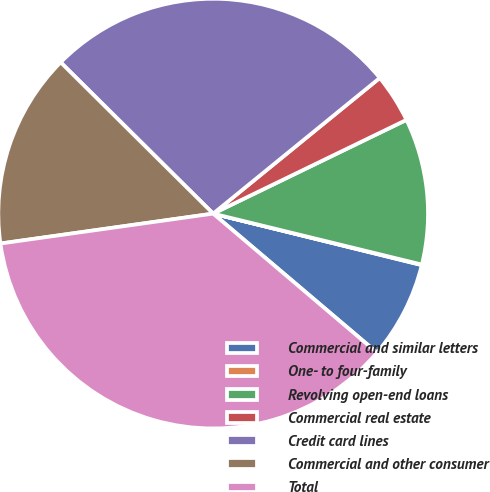Convert chart to OTSL. <chart><loc_0><loc_0><loc_500><loc_500><pie_chart><fcel>Commercial and similar letters<fcel>One- to four-family<fcel>Revolving open-end loans<fcel>Commercial real estate<fcel>Credit card lines<fcel>Commercial and other consumer<fcel>Total<nl><fcel>7.35%<fcel>0.04%<fcel>11.0%<fcel>3.69%<fcel>26.69%<fcel>14.66%<fcel>36.58%<nl></chart> 